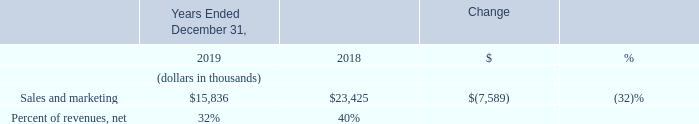Sales and Marketing
Sales and marketing expenses in 2019 decreased by $7.6 million, or 32%, as compared to 2018. This decrease was primarily due to a reduction in the global sales support and marketing headcount, including reductions that were part of our restructuring activities during 2019 (refer to Note 4 of the accompanying consolidated financial statements), contributing to net decreases of $4.8 million in personnel-related costs, and $1.0 million in allocated facilities and information technology costs as compared to 2018. Restructuring costs in 2019 decreased $0.4 million, as there were additional restructuring activities in 2018, including a headcount reduction of approximately 13% of our workforce and the closure of certain leased facilities. The remaining decrease during 2019 was primarily the result of lower marketing costs of $0.6 million, as we eliminated or shifted the timing of certain of our marketing activities.
What is the company's decrease in sales and marketing expenses between 2018 and 2019? $7.6 million. What is the difference in the company's 2019 personnel-related costs as compared to 2018? $4.8 million. What is the company's respective sales and marketing expenses in 2019 and 2018 as a percentage of its revenue? 32%, 40%. What is the company's average sales and marketing expenses in 2018 and 2019?
Answer scale should be: thousand. (15,836 + 23,425)/2 
Answer: 19630.5. What is the value of the change between 2018 and 2019's sales and marketing expenses as a percentage of the 2018 sales and marketing expenses?
Answer scale should be: percent. 7,589/23,425 
Answer: 32.4. What is the value of the change in 2018 and 2019's sales and marketing expenses as a percentage of the 2019 sales and marketing expenses?
Answer scale should be: percent. 7,589/15,836 
Answer: 47.92. 